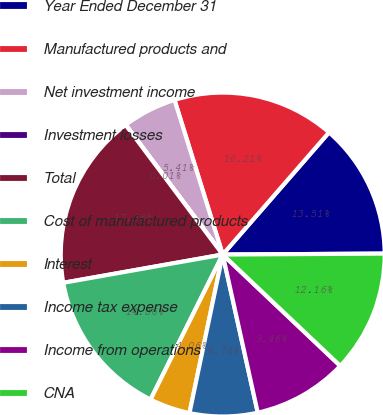<chart> <loc_0><loc_0><loc_500><loc_500><pie_chart><fcel>Year Ended December 31<fcel>Manufactured products and<fcel>Net investment income<fcel>Investment losses<fcel>Total<fcel>Cost of manufactured products<fcel>Interest<fcel>Income tax expense<fcel>Income from operations<fcel>CNA<nl><fcel>13.51%<fcel>16.21%<fcel>5.41%<fcel>0.01%<fcel>17.56%<fcel>14.86%<fcel>4.06%<fcel>6.76%<fcel>9.46%<fcel>12.16%<nl></chart> 